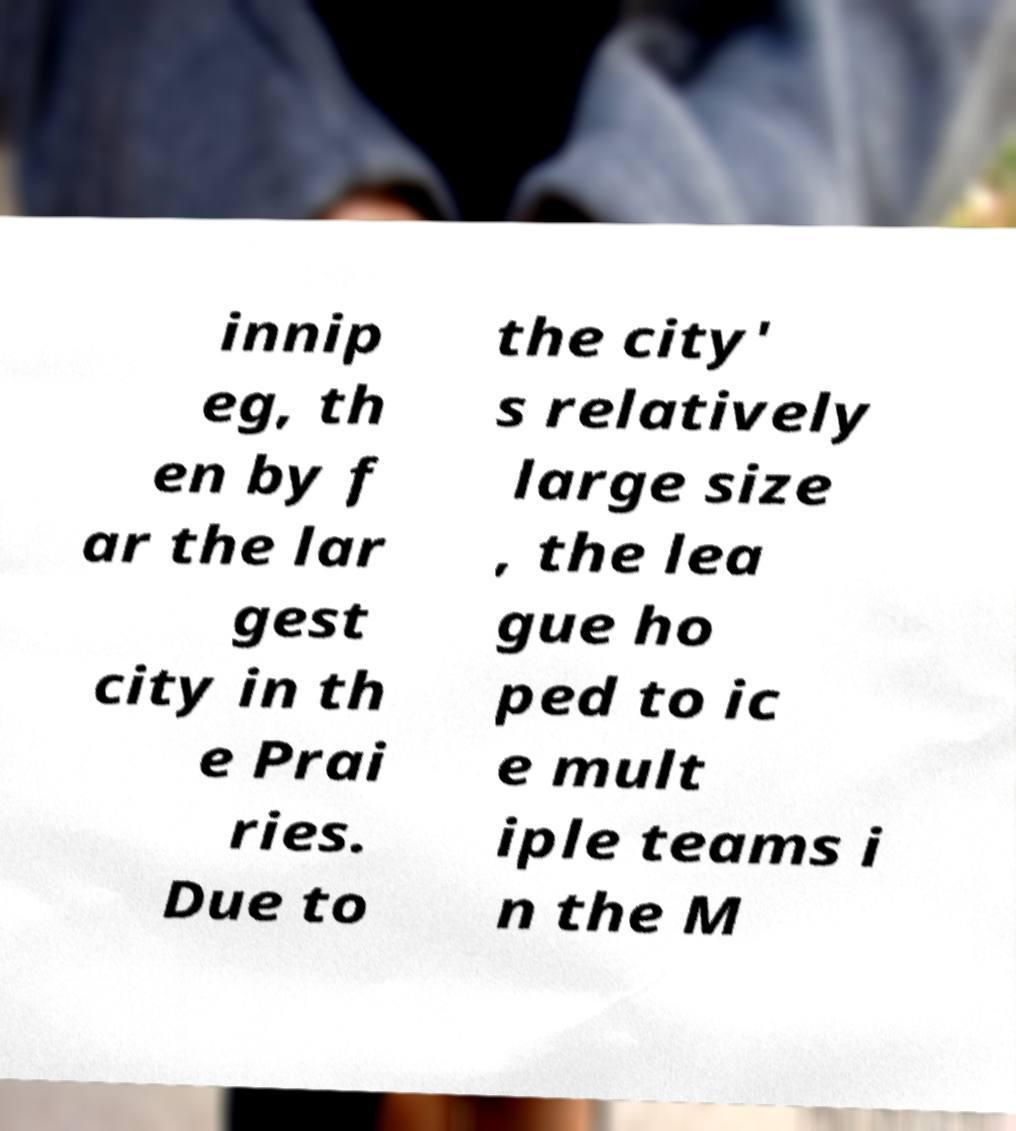What messages or text are displayed in this image? I need them in a readable, typed format. innip eg, th en by f ar the lar gest city in th e Prai ries. Due to the city' s relatively large size , the lea gue ho ped to ic e mult iple teams i n the M 